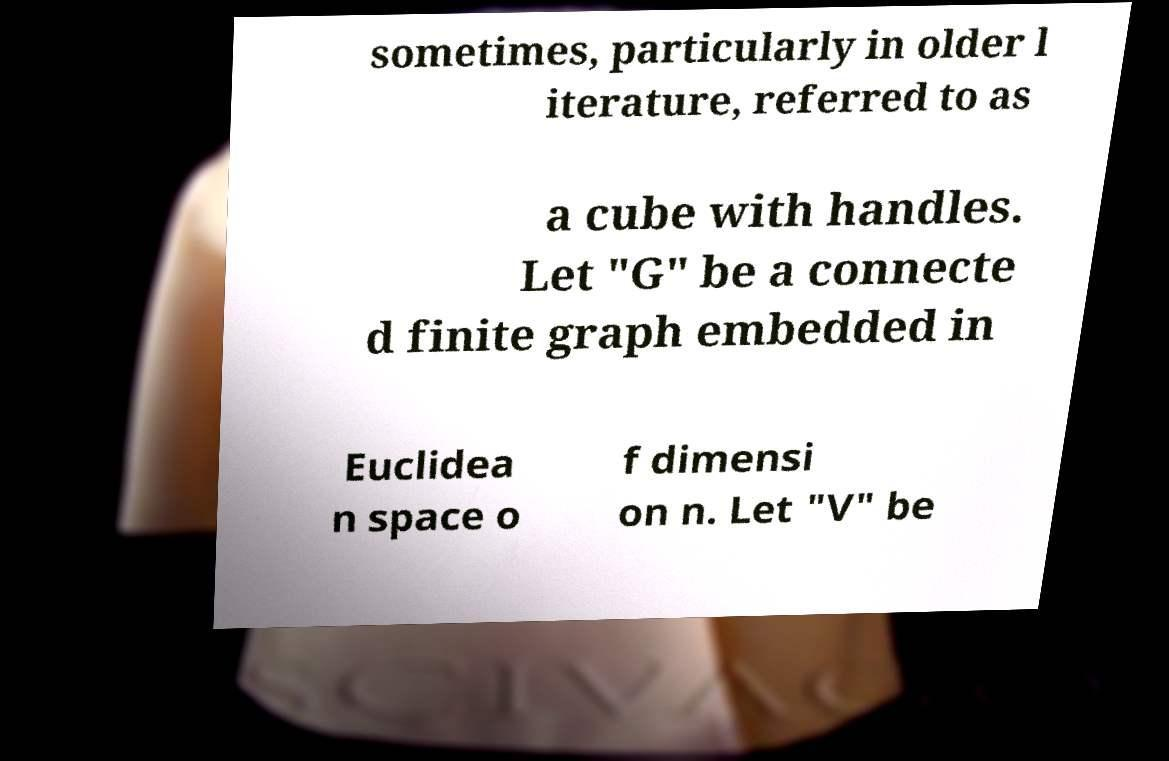Can you accurately transcribe the text from the provided image for me? sometimes, particularly in older l iterature, referred to as a cube with handles. Let "G" be a connecte d finite graph embedded in Euclidea n space o f dimensi on n. Let "V" be 